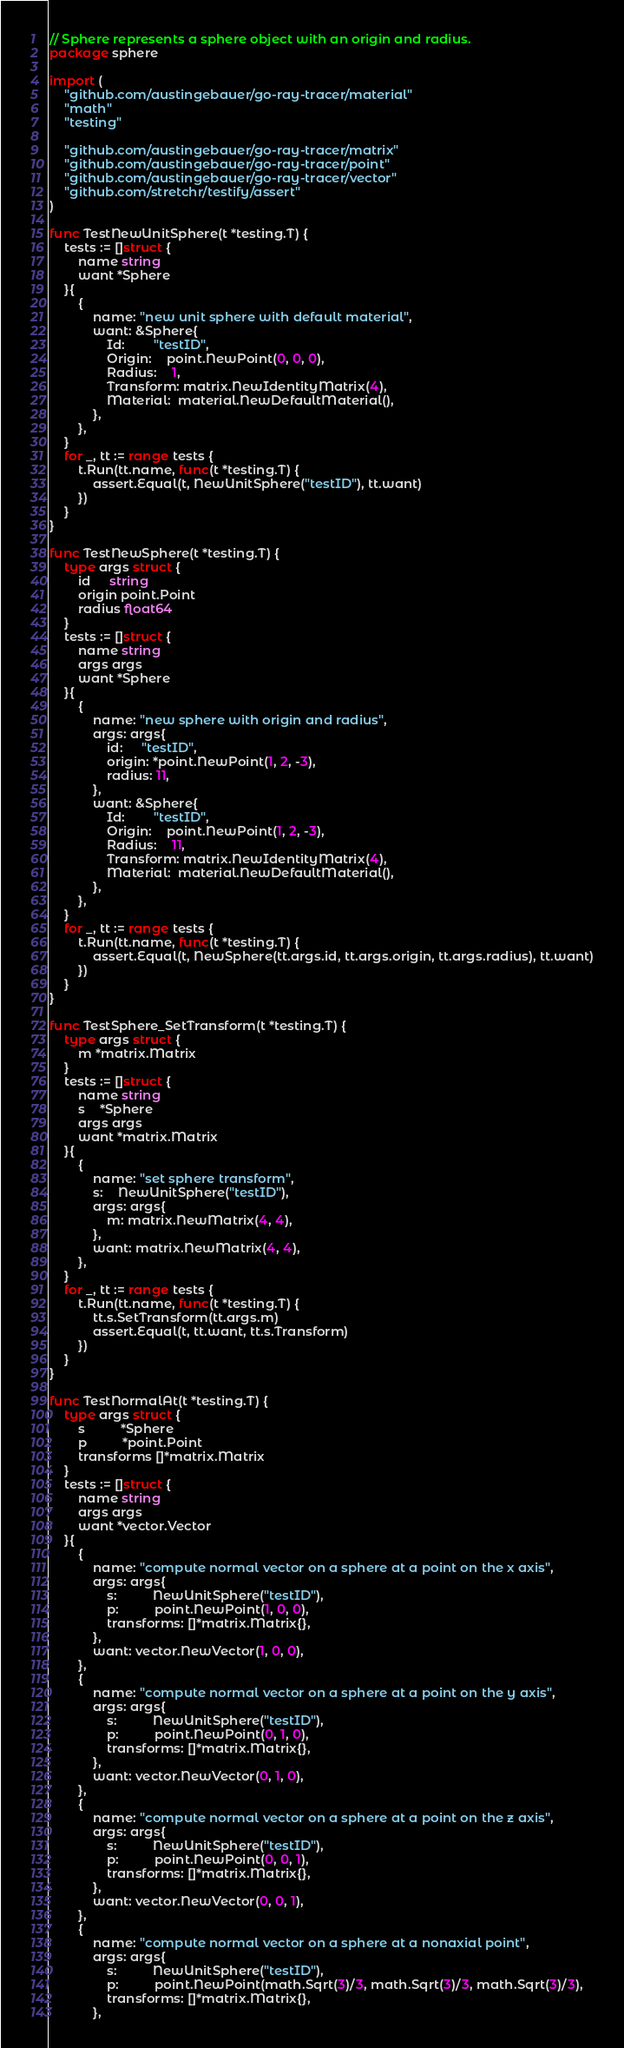Convert code to text. <code><loc_0><loc_0><loc_500><loc_500><_Go_>// Sphere represents a sphere object with an origin and radius.
package sphere

import (
	"github.com/austingebauer/go-ray-tracer/material"
	"math"
	"testing"

	"github.com/austingebauer/go-ray-tracer/matrix"
	"github.com/austingebauer/go-ray-tracer/point"
	"github.com/austingebauer/go-ray-tracer/vector"
	"github.com/stretchr/testify/assert"
)

func TestNewUnitSphere(t *testing.T) {
	tests := []struct {
		name string
		want *Sphere
	}{
		{
			name: "new unit sphere with default material",
			want: &Sphere{
				Id:        "testID",
				Origin:    point.NewPoint(0, 0, 0),
				Radius:    1,
				Transform: matrix.NewIdentityMatrix(4),
				Material:  material.NewDefaultMaterial(),
			},
		},
	}
	for _, tt := range tests {
		t.Run(tt.name, func(t *testing.T) {
			assert.Equal(t, NewUnitSphere("testID"), tt.want)
		})
	}
}

func TestNewSphere(t *testing.T) {
	type args struct {
		id     string
		origin point.Point
		radius float64
	}
	tests := []struct {
		name string
		args args
		want *Sphere
	}{
		{
			name: "new sphere with origin and radius",
			args: args{
				id:     "testID",
				origin: *point.NewPoint(1, 2, -3),
				radius: 11,
			},
			want: &Sphere{
				Id:        "testID",
				Origin:    point.NewPoint(1, 2, -3),
				Radius:    11,
				Transform: matrix.NewIdentityMatrix(4),
				Material:  material.NewDefaultMaterial(),
			},
		},
	}
	for _, tt := range tests {
		t.Run(tt.name, func(t *testing.T) {
			assert.Equal(t, NewSphere(tt.args.id, tt.args.origin, tt.args.radius), tt.want)
		})
	}
}

func TestSphere_SetTransform(t *testing.T) {
	type args struct {
		m *matrix.Matrix
	}
	tests := []struct {
		name string
		s    *Sphere
		args args
		want *matrix.Matrix
	}{
		{
			name: "set sphere transform",
			s:    NewUnitSphere("testID"),
			args: args{
				m: matrix.NewMatrix(4, 4),
			},
			want: matrix.NewMatrix(4, 4),
		},
	}
	for _, tt := range tests {
		t.Run(tt.name, func(t *testing.T) {
			tt.s.SetTransform(tt.args.m)
			assert.Equal(t, tt.want, tt.s.Transform)
		})
	}
}

func TestNormalAt(t *testing.T) {
	type args struct {
		s          *Sphere
		p          *point.Point
		transforms []*matrix.Matrix
	}
	tests := []struct {
		name string
		args args
		want *vector.Vector
	}{
		{
			name: "compute normal vector on a sphere at a point on the x axis",
			args: args{
				s:          NewUnitSphere("testID"),
				p:          point.NewPoint(1, 0, 0),
				transforms: []*matrix.Matrix{},
			},
			want: vector.NewVector(1, 0, 0),
		},
		{
			name: "compute normal vector on a sphere at a point on the y axis",
			args: args{
				s:          NewUnitSphere("testID"),
				p:          point.NewPoint(0, 1, 0),
				transforms: []*matrix.Matrix{},
			},
			want: vector.NewVector(0, 1, 0),
		},
		{
			name: "compute normal vector on a sphere at a point on the z axis",
			args: args{
				s:          NewUnitSphere("testID"),
				p:          point.NewPoint(0, 0, 1),
				transforms: []*matrix.Matrix{},
			},
			want: vector.NewVector(0, 0, 1),
		},
		{
			name: "compute normal vector on a sphere at a nonaxial point",
			args: args{
				s:          NewUnitSphere("testID"),
				p:          point.NewPoint(math.Sqrt(3)/3, math.Sqrt(3)/3, math.Sqrt(3)/3),
				transforms: []*matrix.Matrix{},
			},</code> 